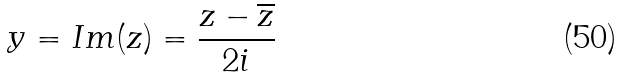Convert formula to latex. <formula><loc_0><loc_0><loc_500><loc_500>y = I m ( z ) = \frac { z - \overline { z } } { 2 i }</formula> 